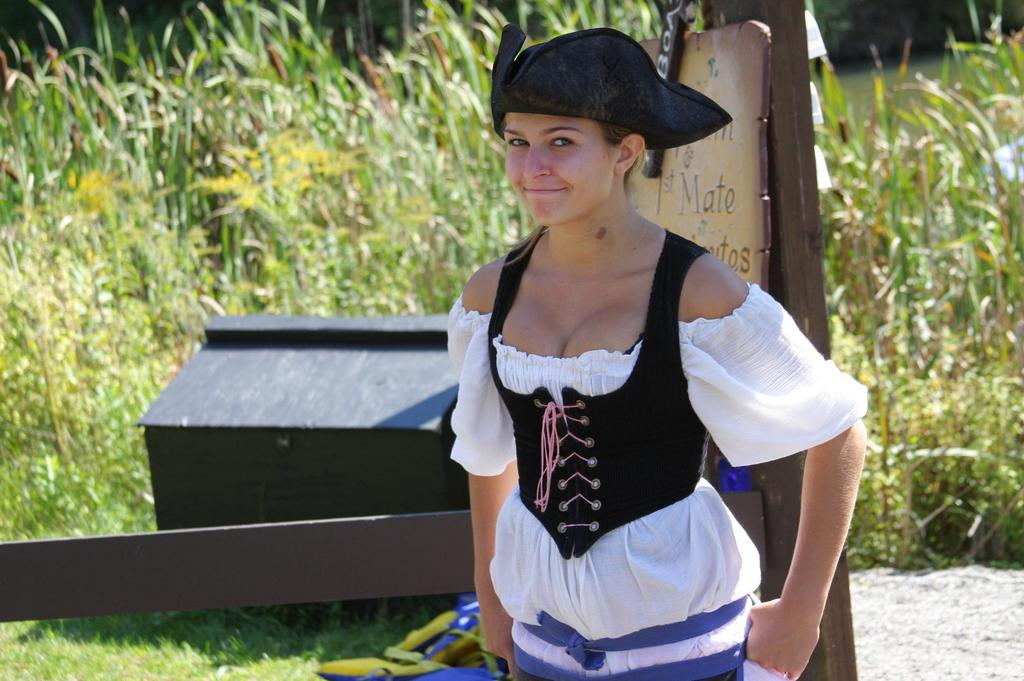Provide a one-sentence caption for the provided image. A woman wearing a triangular pirat's hat is standing in front of the sign that has the word "mate.". 